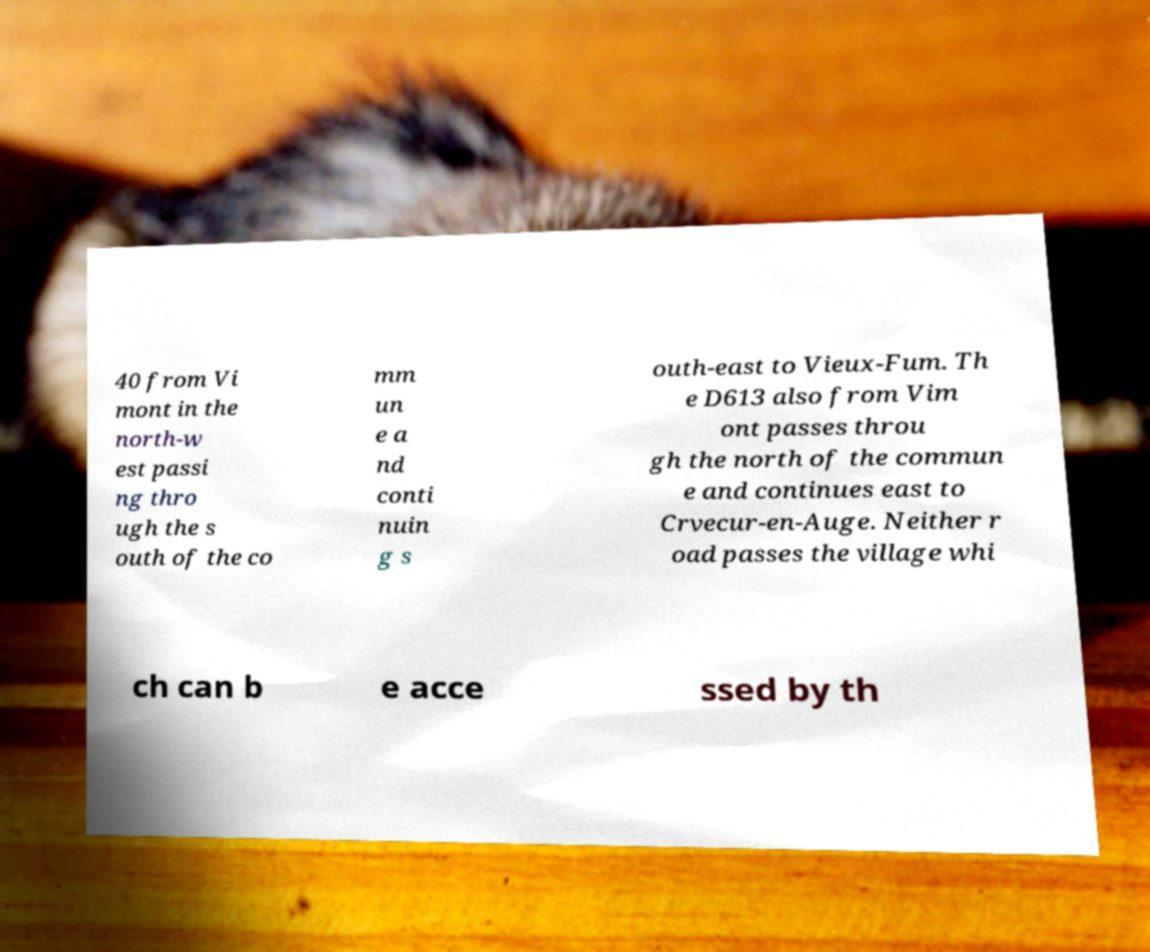I need the written content from this picture converted into text. Can you do that? 40 from Vi mont in the north-w est passi ng thro ugh the s outh of the co mm un e a nd conti nuin g s outh-east to Vieux-Fum. Th e D613 also from Vim ont passes throu gh the north of the commun e and continues east to Crvecur-en-Auge. Neither r oad passes the village whi ch can b e acce ssed by th 